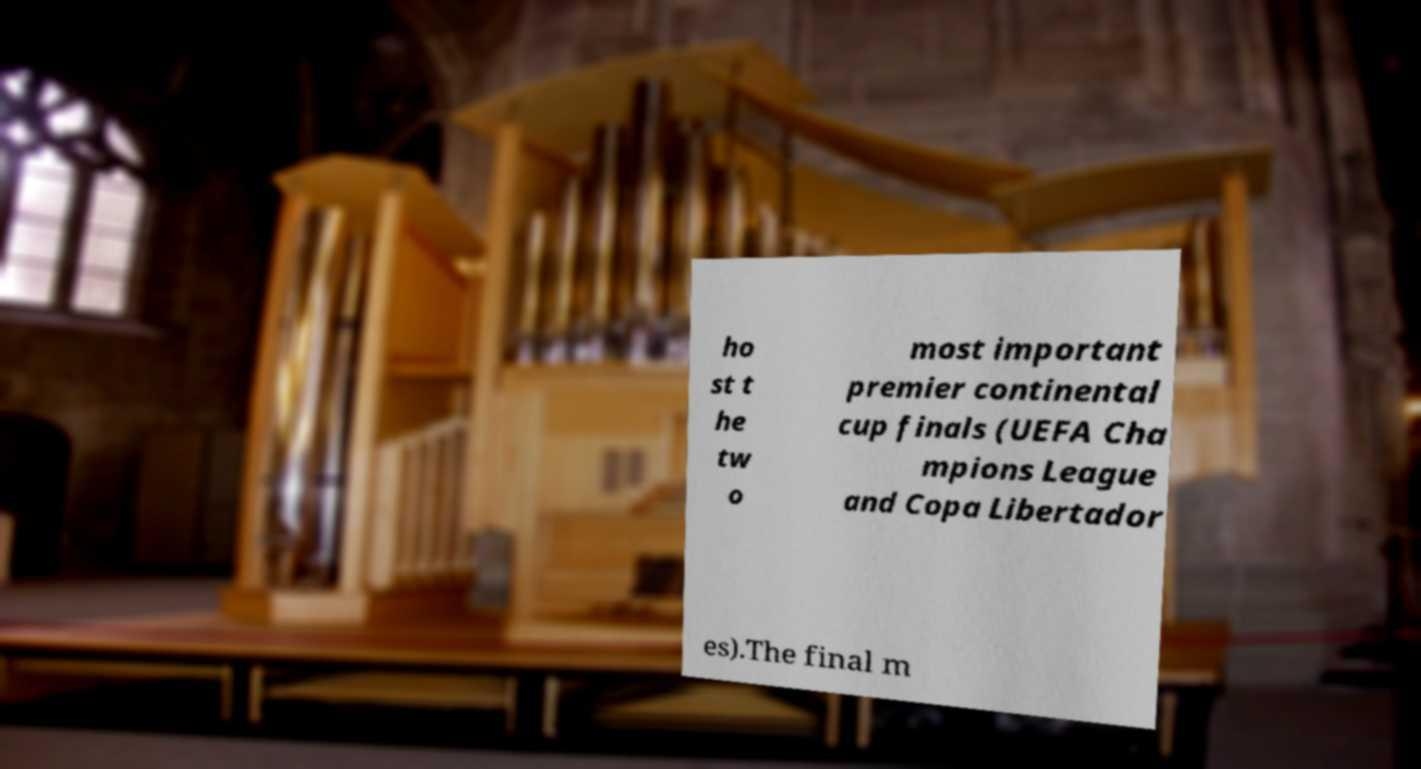For documentation purposes, I need the text within this image transcribed. Could you provide that? ho st t he tw o most important premier continental cup finals (UEFA Cha mpions League and Copa Libertador es).The final m 